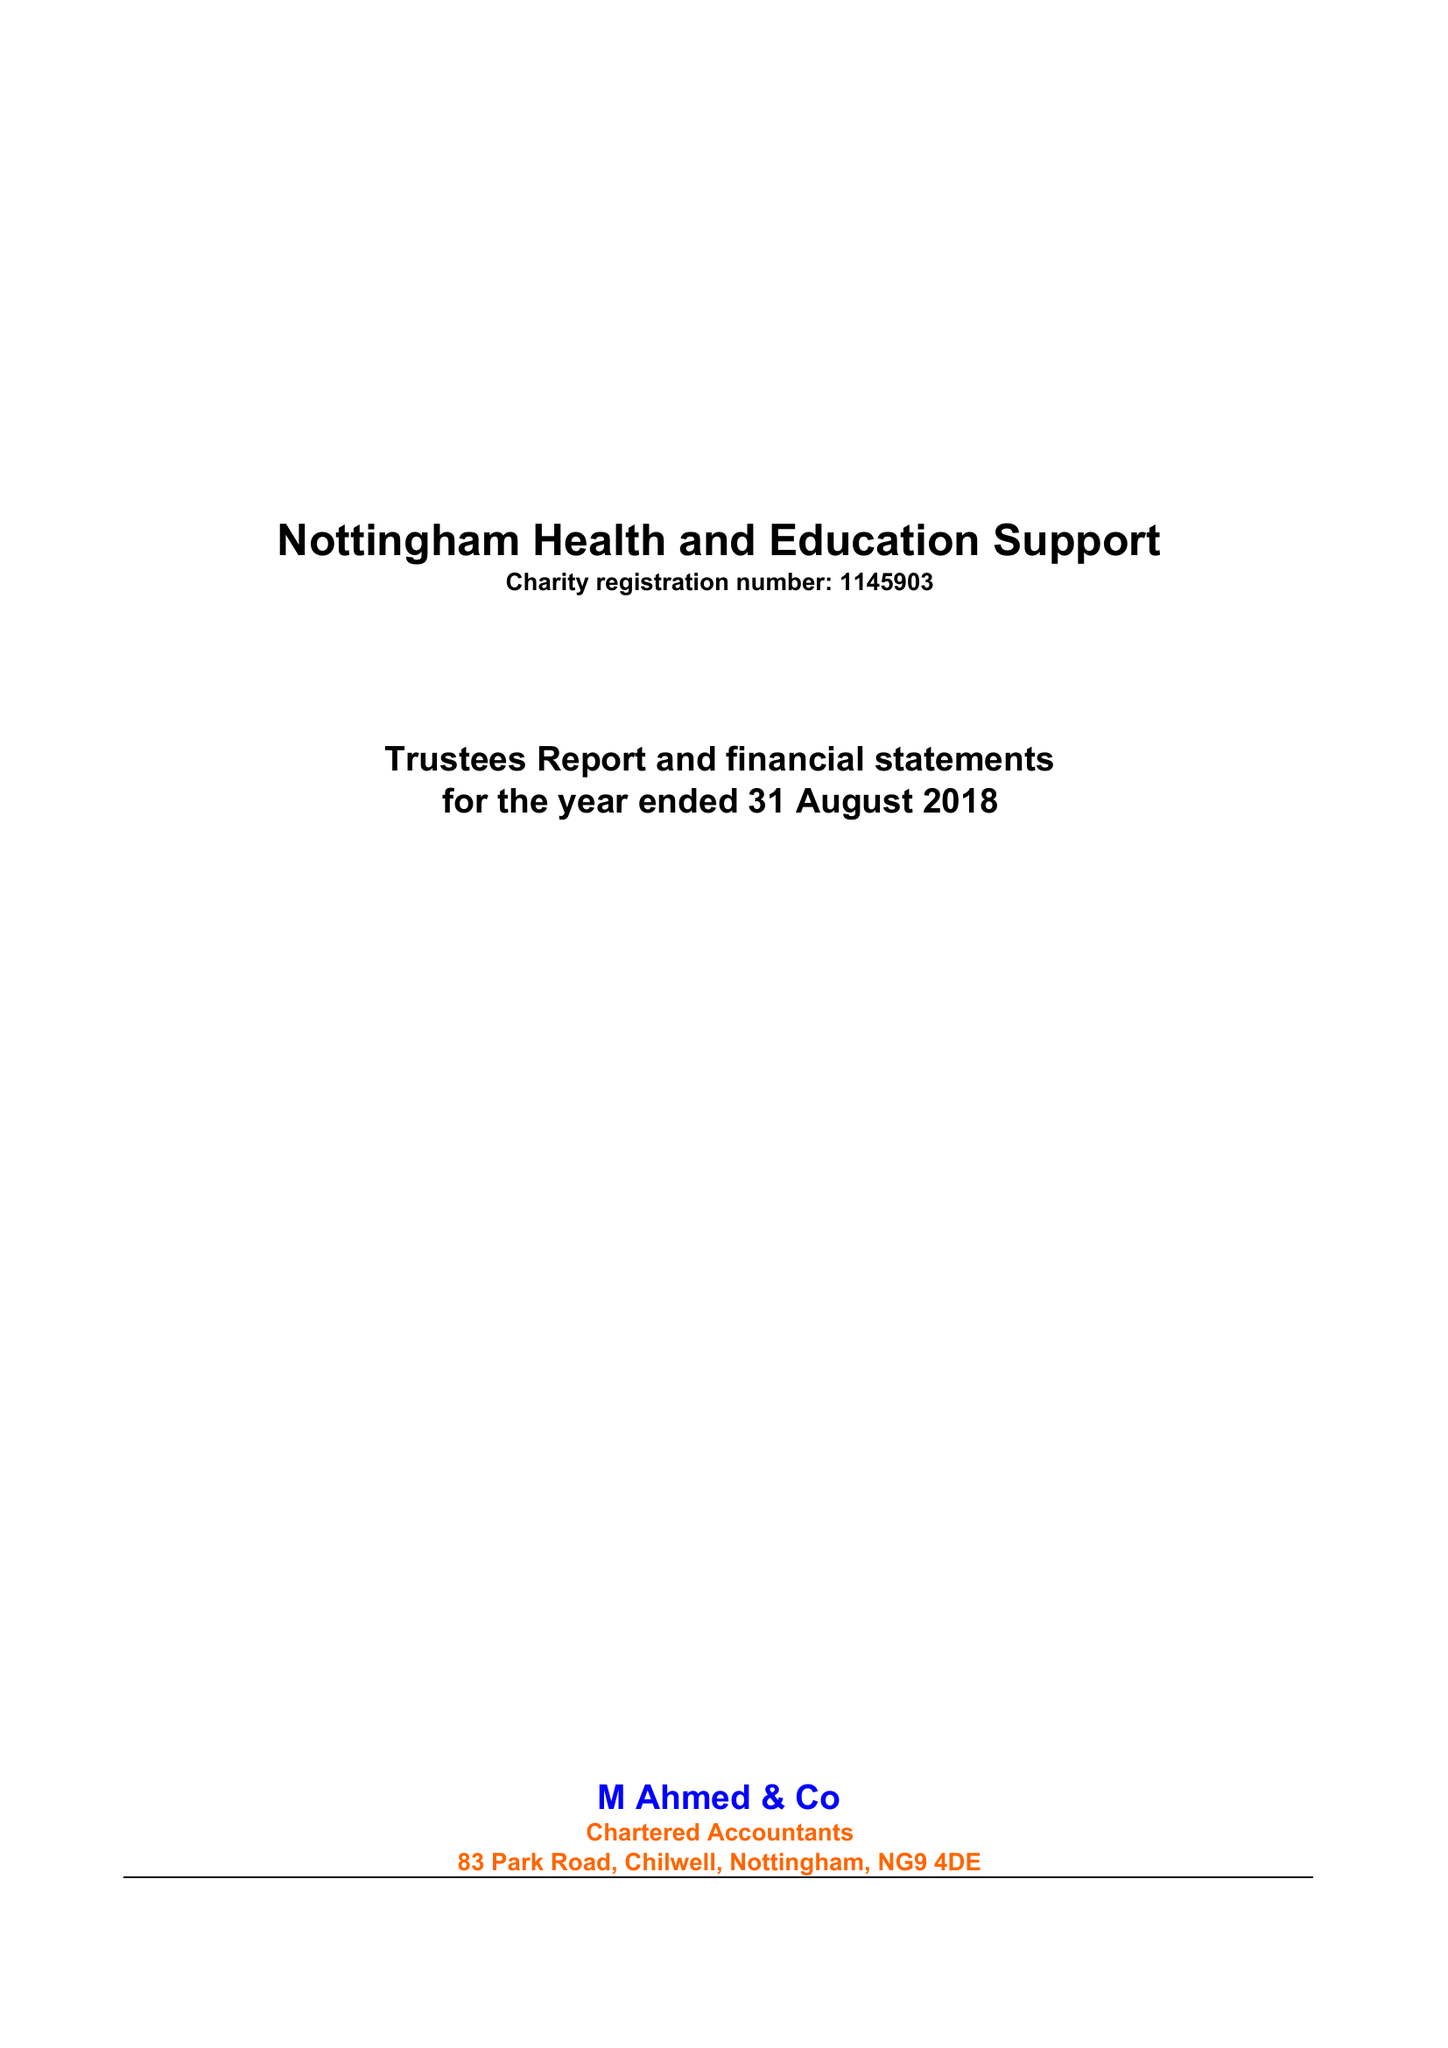What is the value for the charity_number?
Answer the question using a single word or phrase. 1145903 